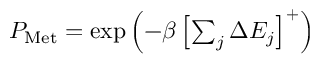Convert formula to latex. <formula><loc_0><loc_0><loc_500><loc_500>\begin{array} { r } { P _ { M e t } = \exp \left ( - \beta \left [ \sum _ { j } \Delta E _ { j } \right ] ^ { + } \right ) } \end{array}</formula> 